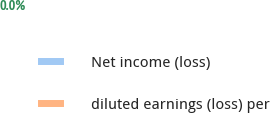Convert chart. <chart><loc_0><loc_0><loc_500><loc_500><pie_chart><fcel>Net income (loss)<fcel>diluted earnings (loss) per<nl><fcel>100.0%<fcel>0.0%<nl></chart> 